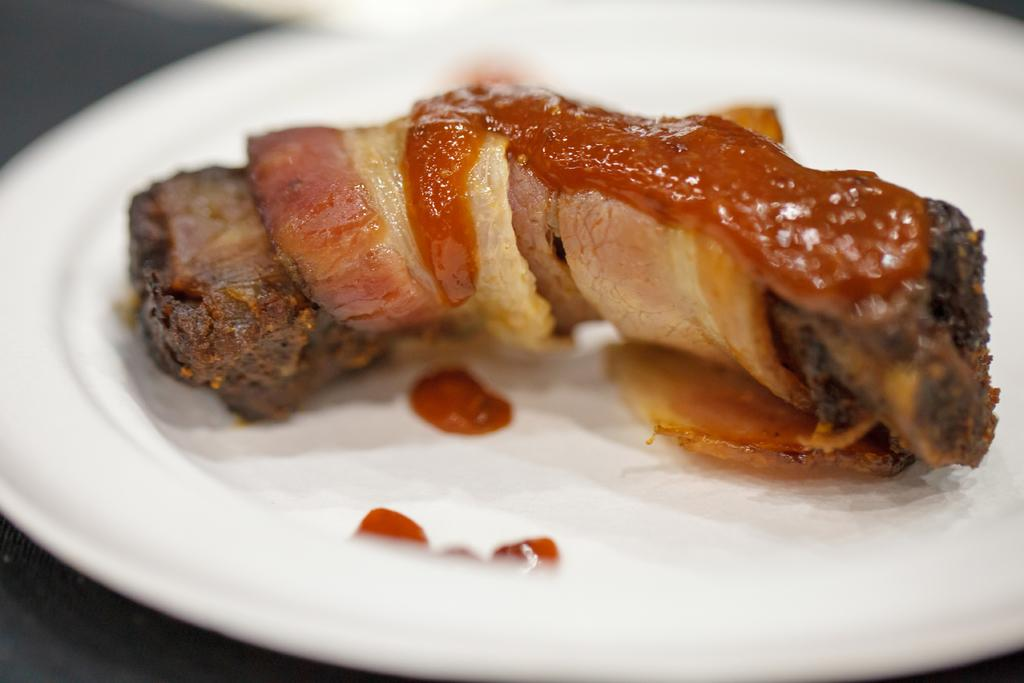What is on the plate in the image? There is a food item on a plate in the image. What color is the plate? The plate is white. Can you describe any other visual elements in the image? A part of the image is blurred. What type of music can be heard playing in the background of the image? There is no music or sound present in the image, as it is a still photograph. 